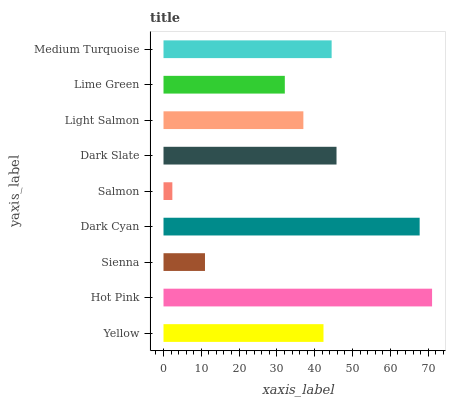Is Salmon the minimum?
Answer yes or no. Yes. Is Hot Pink the maximum?
Answer yes or no. Yes. Is Sienna the minimum?
Answer yes or no. No. Is Sienna the maximum?
Answer yes or no. No. Is Hot Pink greater than Sienna?
Answer yes or no. Yes. Is Sienna less than Hot Pink?
Answer yes or no. Yes. Is Sienna greater than Hot Pink?
Answer yes or no. No. Is Hot Pink less than Sienna?
Answer yes or no. No. Is Yellow the high median?
Answer yes or no. Yes. Is Yellow the low median?
Answer yes or no. Yes. Is Dark Cyan the high median?
Answer yes or no. No. Is Salmon the low median?
Answer yes or no. No. 